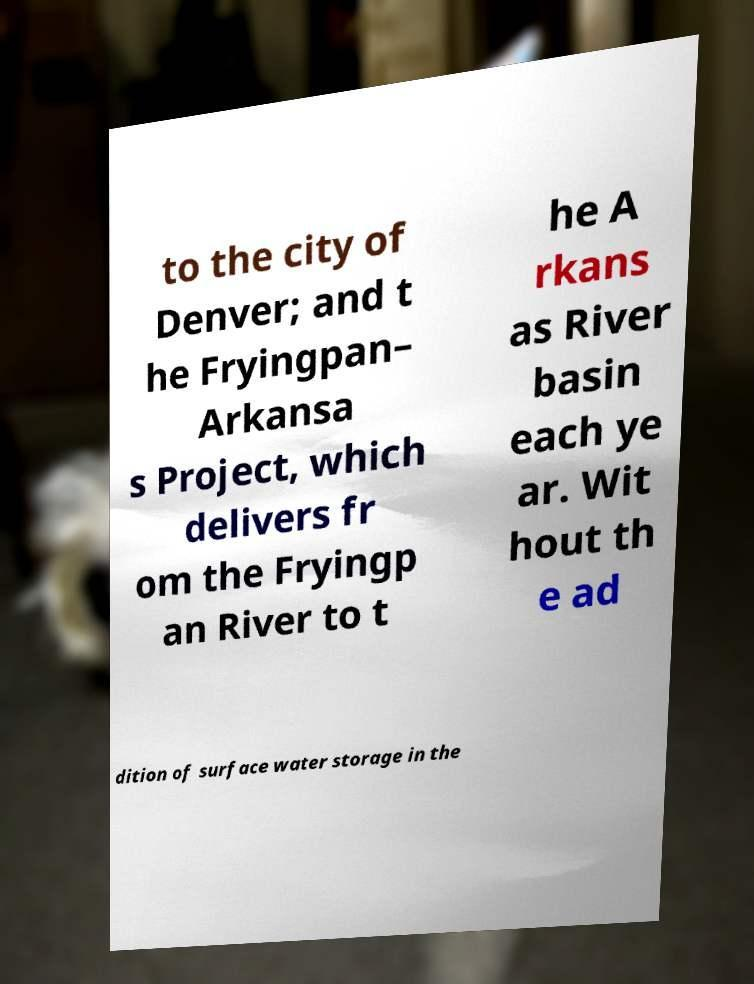What messages or text are displayed in this image? I need them in a readable, typed format. to the city of Denver; and t he Fryingpan– Arkansa s Project, which delivers fr om the Fryingp an River to t he A rkans as River basin each ye ar. Wit hout th e ad dition of surface water storage in the 